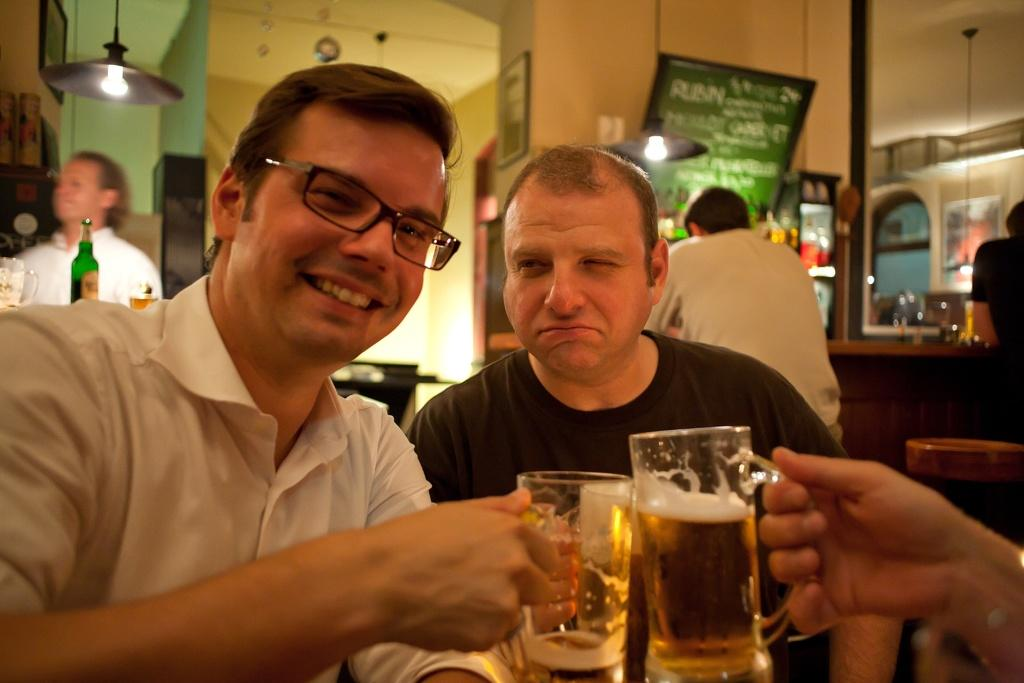How many people are in the image? There are two persons in the image. What are the two persons doing in the image? The two persons are sitting. What activity are the two persons engaged in? The two persons are having a drink. What type of canvas is visible in the image? There is no canvas present in the image. 